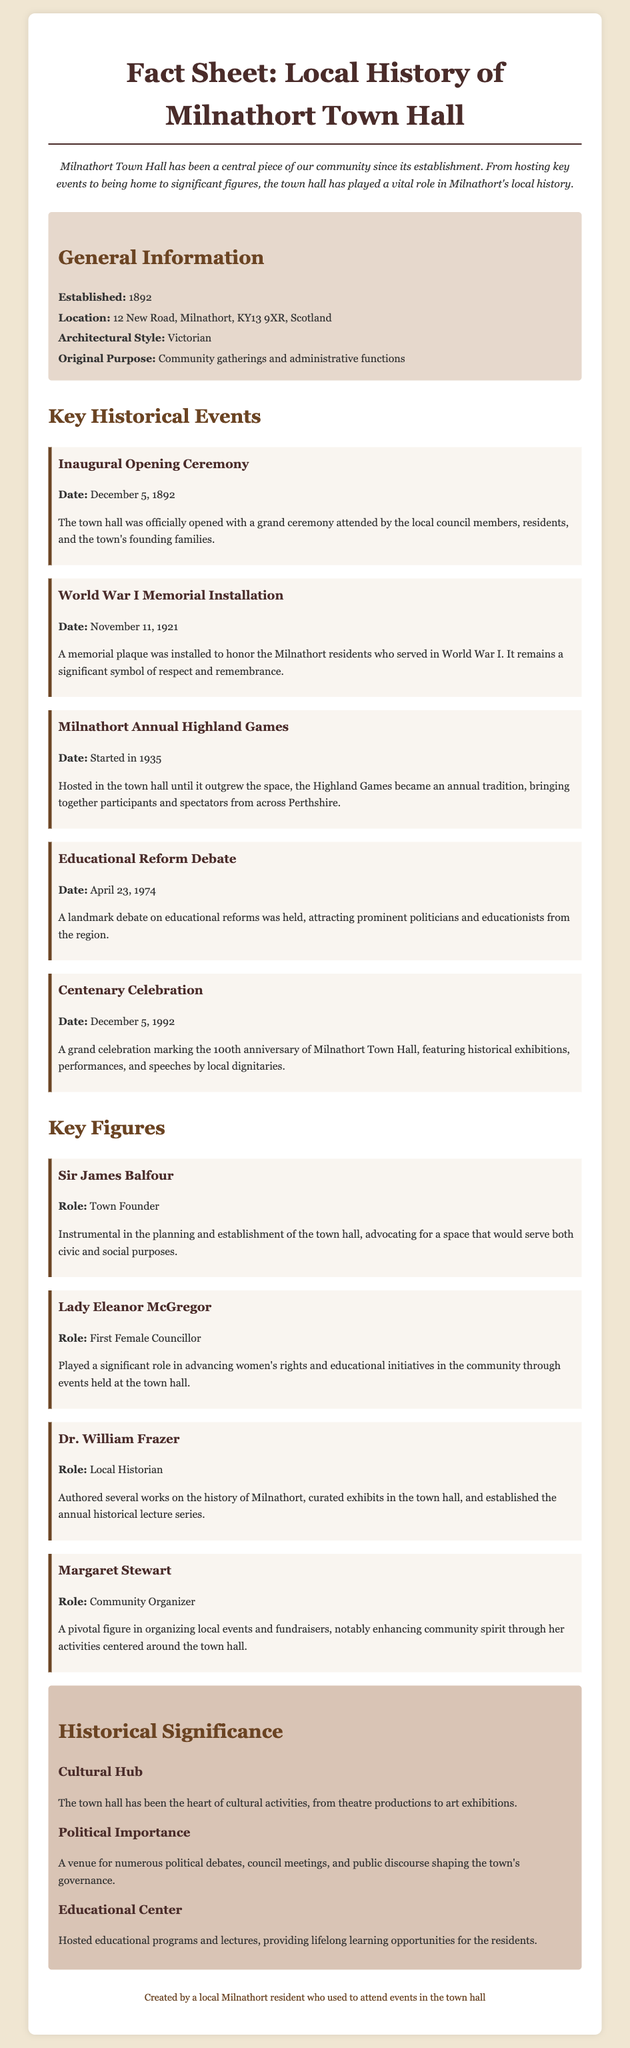What year was Milnathort Town Hall established? The establishment year is provided in the document under general information, which is 1892.
Answer: 1892 What is the architectural style of the Town Hall? The document specifies the architectural style in the general information section, which is described as Victorian.
Answer: Victorian When was the World War I memorial plaque installed? The date for the installation is mentioned in the key historical events section, which is November 11, 1921.
Answer: November 11, 1921 Who was the first female councillor mentioned in the document? The key figures section lists Lady Eleanor McGregor as the first female councillor.
Answer: Lady Eleanor McGregor What significant event took place on April 23, 1974? The document highlights the Educational Reform Debate as a key historical event occurring on this date.
Answer: Educational Reform Debate Why is the Town Hall considered a cultural hub? The document explains that the Town Hall has been the heart of cultural activities, including theatre productions and art exhibitions.
Answer: Cultural activities Who played a pivotal role in advancing women's rights in Milnathort? The document attributes this role to Lady Eleanor McGregor, who held events at the town hall.
Answer: Lady Eleanor McGregor What important feature was installed on November 11, 1921? The document notes the installation of a memorial plaque to honor World War I veterans on this date.
Answer: Memorial plaque What type of events were hosted at the Town Hall until 1935? The document states that the Milnathort Annual Highland Games were hosted at the Town Hall until it outgrew the space.
Answer: Highland Games 